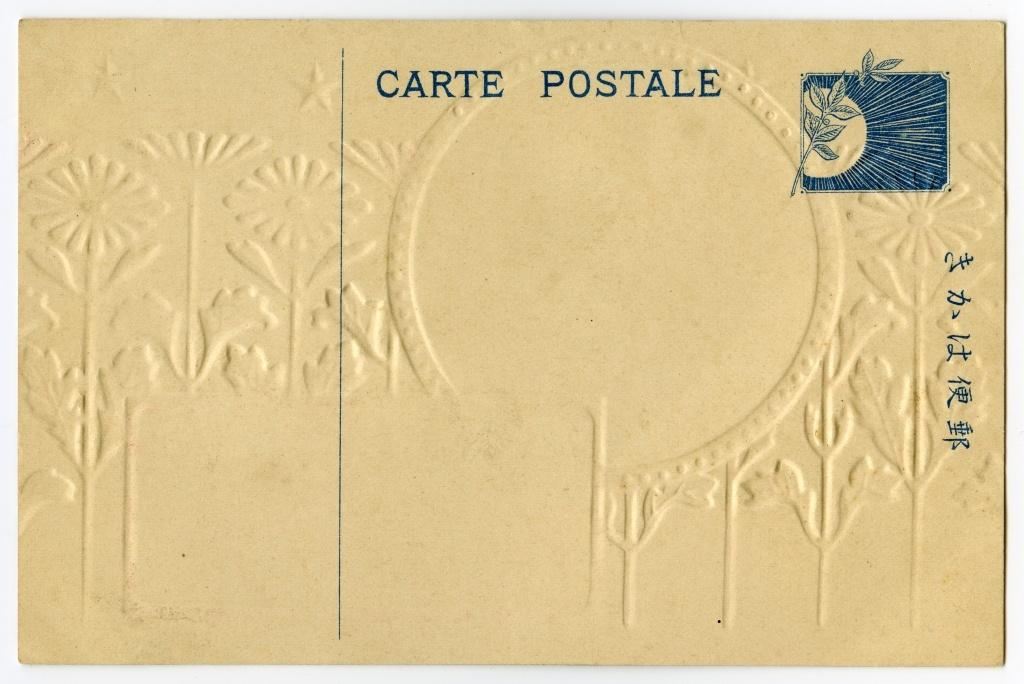<image>
Render a clear and concise summary of the photo. an envelope that has the words 'carte postale' stamped on it 